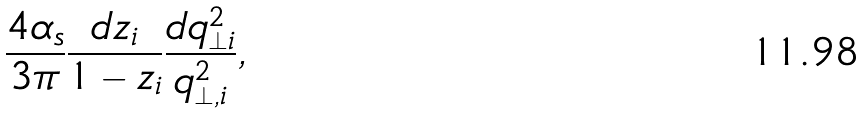<formula> <loc_0><loc_0><loc_500><loc_500>\frac { 4 \alpha _ { s } } { 3 \pi } \frac { d z _ { i } } { 1 - z _ { i } } \frac { d q _ { \perp i } ^ { 2 } } { q _ { \perp , i } ^ { 2 } } ,</formula> 